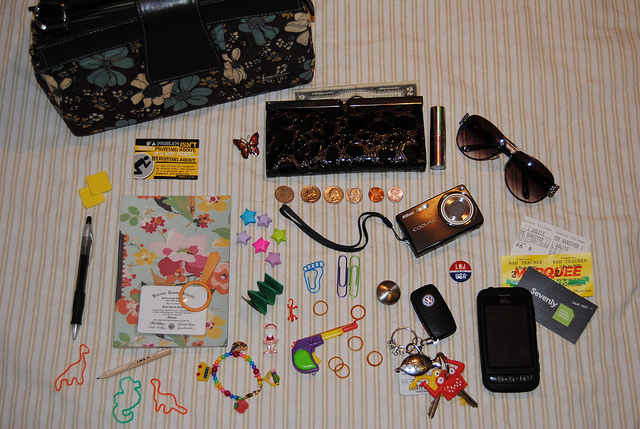Are there any items related to technology in this image? Yes, the image features a few technology-related items including a mobile phone, a digital camera, and what appears to be a portable USB flash drive. These devices suggest a need for connectivity, capturing memories, and data storage. 